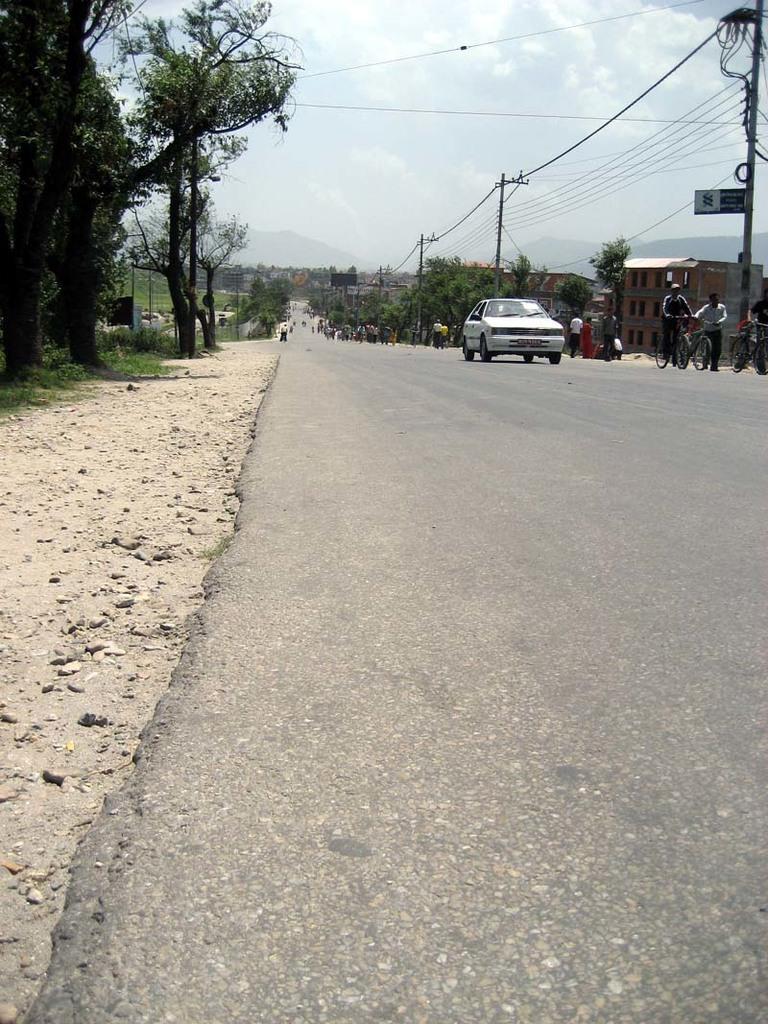Describe this image in one or two sentences. In this picture we can see vehicles, some people are on the road, poles, trees, wires, buildings, some objects, mountains and in the background we can see the sky. 